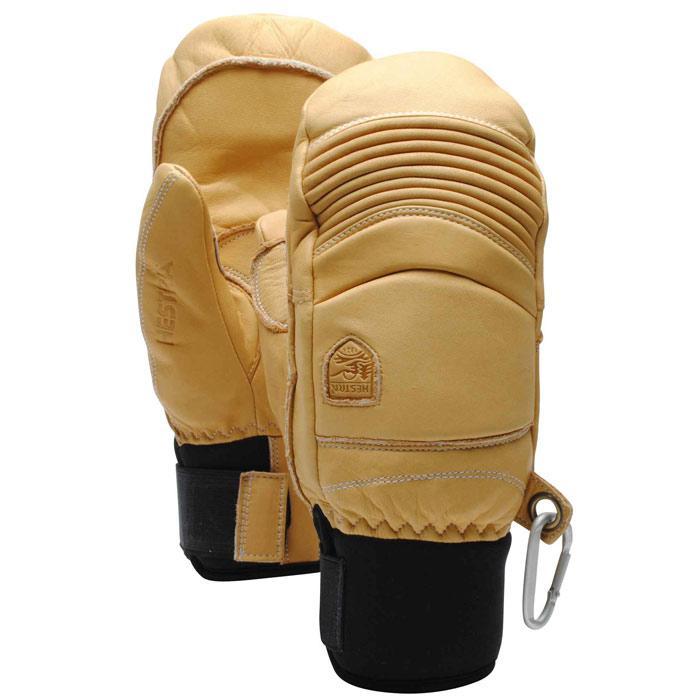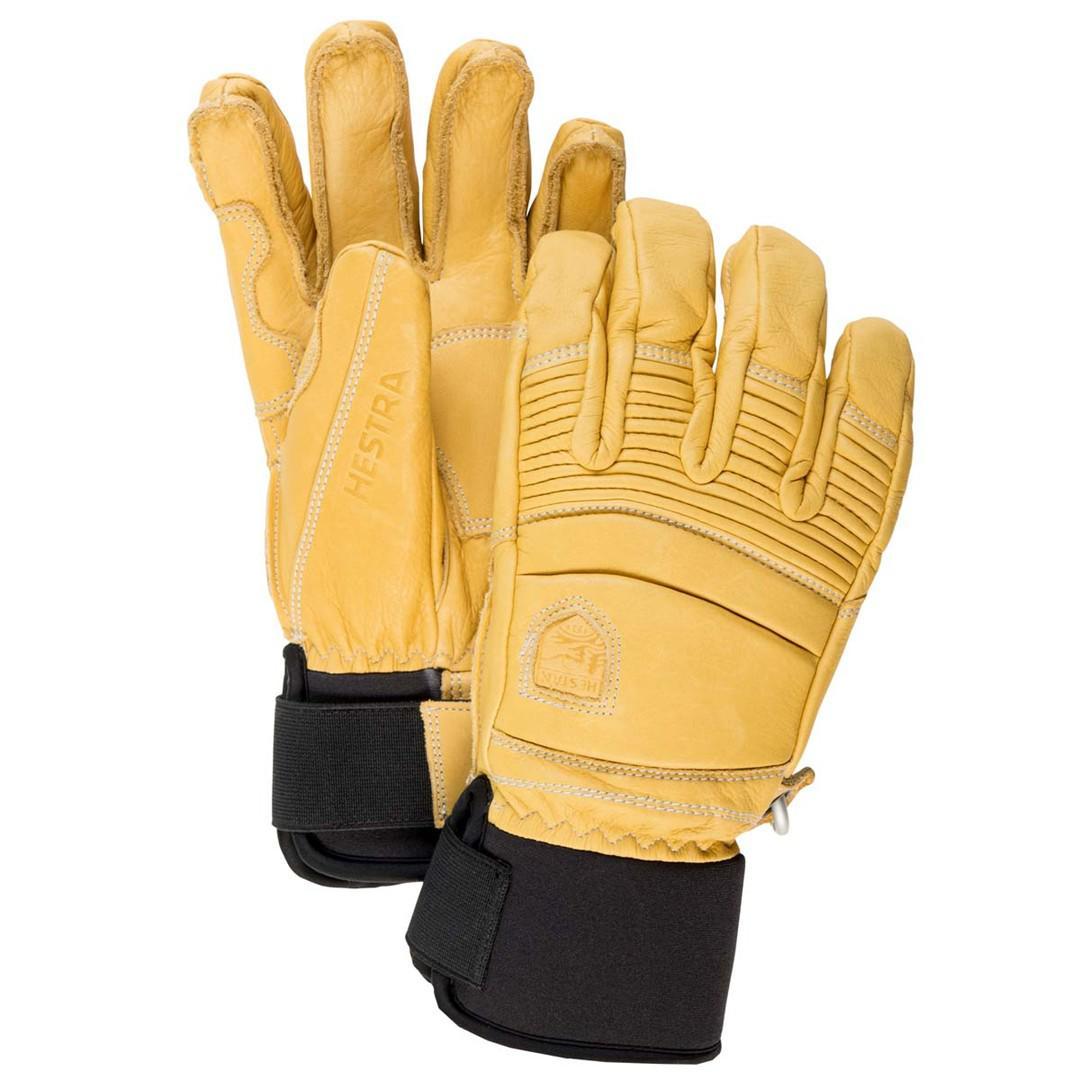The first image is the image on the left, the second image is the image on the right. Given the left and right images, does the statement "Each image shows a pair of work gloves and in one of the images the gloves are a single color." hold true? Answer yes or no. No. 